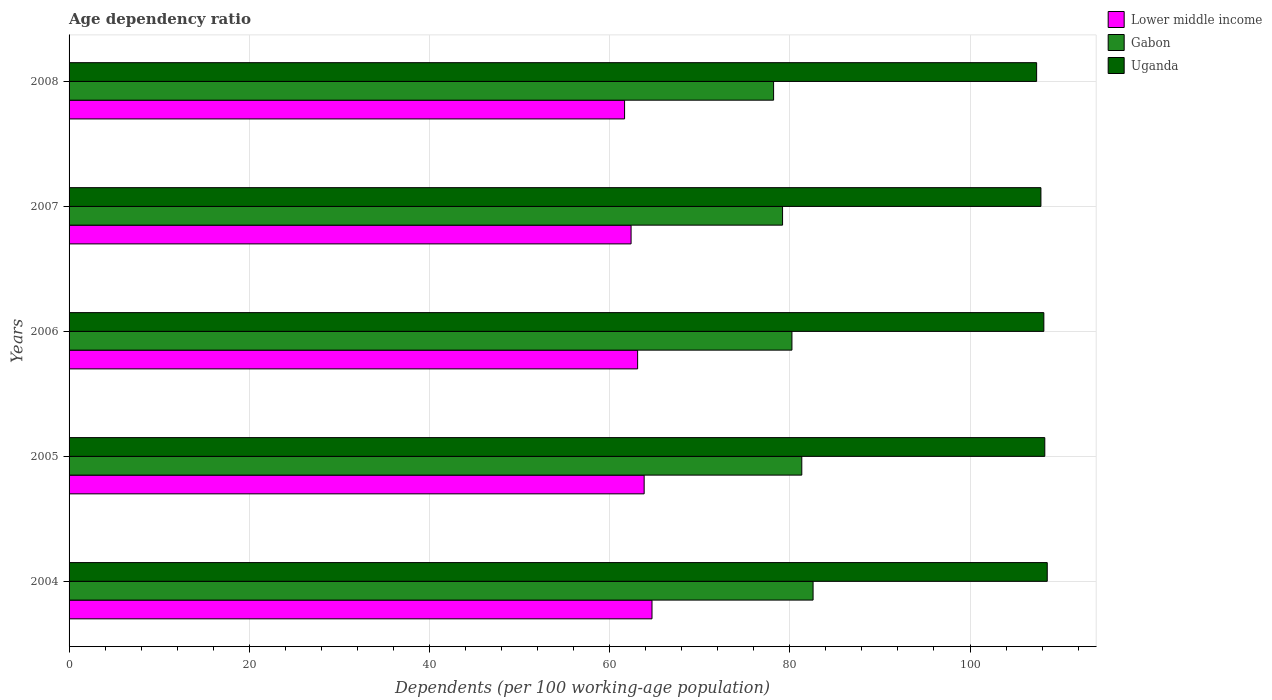How many different coloured bars are there?
Your response must be concise. 3. How many bars are there on the 4th tick from the top?
Make the answer very short. 3. How many bars are there on the 5th tick from the bottom?
Offer a terse response. 3. In how many cases, is the number of bars for a given year not equal to the number of legend labels?
Your answer should be very brief. 0. What is the age dependency ratio in in Uganda in 2006?
Give a very brief answer. 108.19. Across all years, what is the maximum age dependency ratio in in Gabon?
Offer a very short reply. 82.58. Across all years, what is the minimum age dependency ratio in in Lower middle income?
Give a very brief answer. 61.66. What is the total age dependency ratio in in Uganda in the graph?
Ensure brevity in your answer.  540.33. What is the difference between the age dependency ratio in in Uganda in 2004 and that in 2007?
Your answer should be compact. 0.7. What is the difference between the age dependency ratio in in Lower middle income in 2004 and the age dependency ratio in in Uganda in 2008?
Offer a terse response. -42.69. What is the average age dependency ratio in in Uganda per year?
Offer a very short reply. 108.07. In the year 2007, what is the difference between the age dependency ratio in in Gabon and age dependency ratio in in Lower middle income?
Provide a short and direct response. 16.81. What is the ratio of the age dependency ratio in in Gabon in 2005 to that in 2007?
Provide a succinct answer. 1.03. Is the age dependency ratio in in Lower middle income in 2005 less than that in 2006?
Your response must be concise. No. Is the difference between the age dependency ratio in in Gabon in 2005 and 2008 greater than the difference between the age dependency ratio in in Lower middle income in 2005 and 2008?
Provide a succinct answer. Yes. What is the difference between the highest and the second highest age dependency ratio in in Gabon?
Offer a terse response. 1.25. What is the difference between the highest and the lowest age dependency ratio in in Lower middle income?
Make the answer very short. 3.04. In how many years, is the age dependency ratio in in Gabon greater than the average age dependency ratio in in Gabon taken over all years?
Your answer should be very brief. 2. What does the 1st bar from the top in 2008 represents?
Give a very brief answer. Uganda. What does the 3rd bar from the bottom in 2006 represents?
Ensure brevity in your answer.  Uganda. Are all the bars in the graph horizontal?
Make the answer very short. Yes. How many years are there in the graph?
Your answer should be compact. 5. Are the values on the major ticks of X-axis written in scientific E-notation?
Offer a very short reply. No. Where does the legend appear in the graph?
Make the answer very short. Top right. How many legend labels are there?
Ensure brevity in your answer.  3. What is the title of the graph?
Provide a succinct answer. Age dependency ratio. Does "European Union" appear as one of the legend labels in the graph?
Your answer should be very brief. No. What is the label or title of the X-axis?
Ensure brevity in your answer.  Dependents (per 100 working-age population). What is the Dependents (per 100 working-age population) in Lower middle income in 2004?
Offer a terse response. 64.7. What is the Dependents (per 100 working-age population) of Gabon in 2004?
Give a very brief answer. 82.58. What is the Dependents (per 100 working-age population) of Uganda in 2004?
Make the answer very short. 108.57. What is the Dependents (per 100 working-age population) of Lower middle income in 2005?
Make the answer very short. 63.83. What is the Dependents (per 100 working-age population) of Gabon in 2005?
Give a very brief answer. 81.33. What is the Dependents (per 100 working-age population) of Uganda in 2005?
Give a very brief answer. 108.3. What is the Dependents (per 100 working-age population) of Lower middle income in 2006?
Make the answer very short. 63.11. What is the Dependents (per 100 working-age population) in Gabon in 2006?
Your answer should be compact. 80.23. What is the Dependents (per 100 working-age population) in Uganda in 2006?
Your answer should be very brief. 108.19. What is the Dependents (per 100 working-age population) in Lower middle income in 2007?
Your answer should be very brief. 62.38. What is the Dependents (per 100 working-age population) in Gabon in 2007?
Make the answer very short. 79.19. What is the Dependents (per 100 working-age population) of Uganda in 2007?
Provide a short and direct response. 107.87. What is the Dependents (per 100 working-age population) of Lower middle income in 2008?
Provide a succinct answer. 61.66. What is the Dependents (per 100 working-age population) in Gabon in 2008?
Your answer should be very brief. 78.2. What is the Dependents (per 100 working-age population) in Uganda in 2008?
Give a very brief answer. 107.39. Across all years, what is the maximum Dependents (per 100 working-age population) in Lower middle income?
Make the answer very short. 64.7. Across all years, what is the maximum Dependents (per 100 working-age population) in Gabon?
Keep it short and to the point. 82.58. Across all years, what is the maximum Dependents (per 100 working-age population) in Uganda?
Give a very brief answer. 108.57. Across all years, what is the minimum Dependents (per 100 working-age population) in Lower middle income?
Your response must be concise. 61.66. Across all years, what is the minimum Dependents (per 100 working-age population) of Gabon?
Make the answer very short. 78.2. Across all years, what is the minimum Dependents (per 100 working-age population) of Uganda?
Provide a succinct answer. 107.39. What is the total Dependents (per 100 working-age population) of Lower middle income in the graph?
Your answer should be very brief. 315.68. What is the total Dependents (per 100 working-age population) in Gabon in the graph?
Provide a short and direct response. 401.54. What is the total Dependents (per 100 working-age population) of Uganda in the graph?
Offer a terse response. 540.33. What is the difference between the Dependents (per 100 working-age population) of Lower middle income in 2004 and that in 2005?
Ensure brevity in your answer.  0.87. What is the difference between the Dependents (per 100 working-age population) of Gabon in 2004 and that in 2005?
Provide a short and direct response. 1.25. What is the difference between the Dependents (per 100 working-age population) of Uganda in 2004 and that in 2005?
Provide a short and direct response. 0.27. What is the difference between the Dependents (per 100 working-age population) of Lower middle income in 2004 and that in 2006?
Provide a succinct answer. 1.59. What is the difference between the Dependents (per 100 working-age population) in Gabon in 2004 and that in 2006?
Offer a terse response. 2.35. What is the difference between the Dependents (per 100 working-age population) in Uganda in 2004 and that in 2006?
Your answer should be compact. 0.38. What is the difference between the Dependents (per 100 working-age population) of Lower middle income in 2004 and that in 2007?
Your answer should be very brief. 2.32. What is the difference between the Dependents (per 100 working-age population) in Gabon in 2004 and that in 2007?
Your response must be concise. 3.39. What is the difference between the Dependents (per 100 working-age population) in Uganda in 2004 and that in 2007?
Ensure brevity in your answer.  0.7. What is the difference between the Dependents (per 100 working-age population) in Lower middle income in 2004 and that in 2008?
Your response must be concise. 3.04. What is the difference between the Dependents (per 100 working-age population) of Gabon in 2004 and that in 2008?
Ensure brevity in your answer.  4.38. What is the difference between the Dependents (per 100 working-age population) of Uganda in 2004 and that in 2008?
Provide a succinct answer. 1.18. What is the difference between the Dependents (per 100 working-age population) of Lower middle income in 2005 and that in 2006?
Your answer should be very brief. 0.72. What is the difference between the Dependents (per 100 working-age population) of Gabon in 2005 and that in 2006?
Your answer should be compact. 1.1. What is the difference between the Dependents (per 100 working-age population) in Uganda in 2005 and that in 2006?
Your response must be concise. 0.11. What is the difference between the Dependents (per 100 working-age population) of Lower middle income in 2005 and that in 2007?
Your answer should be compact. 1.45. What is the difference between the Dependents (per 100 working-age population) of Gabon in 2005 and that in 2007?
Your response must be concise. 2.13. What is the difference between the Dependents (per 100 working-age population) of Uganda in 2005 and that in 2007?
Ensure brevity in your answer.  0.43. What is the difference between the Dependents (per 100 working-age population) in Lower middle income in 2005 and that in 2008?
Make the answer very short. 2.17. What is the difference between the Dependents (per 100 working-age population) of Gabon in 2005 and that in 2008?
Your answer should be very brief. 3.13. What is the difference between the Dependents (per 100 working-age population) of Uganda in 2005 and that in 2008?
Provide a succinct answer. 0.91. What is the difference between the Dependents (per 100 working-age population) of Lower middle income in 2006 and that in 2007?
Your answer should be very brief. 0.73. What is the difference between the Dependents (per 100 working-age population) in Gabon in 2006 and that in 2007?
Give a very brief answer. 1.04. What is the difference between the Dependents (per 100 working-age population) of Uganda in 2006 and that in 2007?
Your answer should be very brief. 0.32. What is the difference between the Dependents (per 100 working-age population) in Lower middle income in 2006 and that in 2008?
Offer a terse response. 1.45. What is the difference between the Dependents (per 100 working-age population) of Gabon in 2006 and that in 2008?
Offer a very short reply. 2.04. What is the difference between the Dependents (per 100 working-age population) of Uganda in 2006 and that in 2008?
Give a very brief answer. 0.8. What is the difference between the Dependents (per 100 working-age population) of Lower middle income in 2007 and that in 2008?
Provide a succinct answer. 0.72. What is the difference between the Dependents (per 100 working-age population) of Gabon in 2007 and that in 2008?
Offer a very short reply. 1. What is the difference between the Dependents (per 100 working-age population) of Uganda in 2007 and that in 2008?
Give a very brief answer. 0.48. What is the difference between the Dependents (per 100 working-age population) of Lower middle income in 2004 and the Dependents (per 100 working-age population) of Gabon in 2005?
Your answer should be very brief. -16.63. What is the difference between the Dependents (per 100 working-age population) in Lower middle income in 2004 and the Dependents (per 100 working-age population) in Uganda in 2005?
Provide a short and direct response. -43.6. What is the difference between the Dependents (per 100 working-age population) of Gabon in 2004 and the Dependents (per 100 working-age population) of Uganda in 2005?
Your answer should be very brief. -25.72. What is the difference between the Dependents (per 100 working-age population) of Lower middle income in 2004 and the Dependents (per 100 working-age population) of Gabon in 2006?
Offer a very short reply. -15.53. What is the difference between the Dependents (per 100 working-age population) of Lower middle income in 2004 and the Dependents (per 100 working-age population) of Uganda in 2006?
Provide a short and direct response. -43.49. What is the difference between the Dependents (per 100 working-age population) in Gabon in 2004 and the Dependents (per 100 working-age population) in Uganda in 2006?
Offer a terse response. -25.61. What is the difference between the Dependents (per 100 working-age population) of Lower middle income in 2004 and the Dependents (per 100 working-age population) of Gabon in 2007?
Your answer should be compact. -14.49. What is the difference between the Dependents (per 100 working-age population) of Lower middle income in 2004 and the Dependents (per 100 working-age population) of Uganda in 2007?
Provide a short and direct response. -43.17. What is the difference between the Dependents (per 100 working-age population) in Gabon in 2004 and the Dependents (per 100 working-age population) in Uganda in 2007?
Ensure brevity in your answer.  -25.29. What is the difference between the Dependents (per 100 working-age population) of Lower middle income in 2004 and the Dependents (per 100 working-age population) of Gabon in 2008?
Ensure brevity in your answer.  -13.5. What is the difference between the Dependents (per 100 working-age population) in Lower middle income in 2004 and the Dependents (per 100 working-age population) in Uganda in 2008?
Ensure brevity in your answer.  -42.69. What is the difference between the Dependents (per 100 working-age population) in Gabon in 2004 and the Dependents (per 100 working-age population) in Uganda in 2008?
Provide a succinct answer. -24.81. What is the difference between the Dependents (per 100 working-age population) in Lower middle income in 2005 and the Dependents (per 100 working-age population) in Gabon in 2006?
Keep it short and to the point. -16.4. What is the difference between the Dependents (per 100 working-age population) in Lower middle income in 2005 and the Dependents (per 100 working-age population) in Uganda in 2006?
Provide a succinct answer. -44.36. What is the difference between the Dependents (per 100 working-age population) of Gabon in 2005 and the Dependents (per 100 working-age population) of Uganda in 2006?
Keep it short and to the point. -26.87. What is the difference between the Dependents (per 100 working-age population) of Lower middle income in 2005 and the Dependents (per 100 working-age population) of Gabon in 2007?
Keep it short and to the point. -15.36. What is the difference between the Dependents (per 100 working-age population) of Lower middle income in 2005 and the Dependents (per 100 working-age population) of Uganda in 2007?
Offer a terse response. -44.04. What is the difference between the Dependents (per 100 working-age population) in Gabon in 2005 and the Dependents (per 100 working-age population) in Uganda in 2007?
Keep it short and to the point. -26.54. What is the difference between the Dependents (per 100 working-age population) in Lower middle income in 2005 and the Dependents (per 100 working-age population) in Gabon in 2008?
Make the answer very short. -14.37. What is the difference between the Dependents (per 100 working-age population) in Lower middle income in 2005 and the Dependents (per 100 working-age population) in Uganda in 2008?
Make the answer very short. -43.56. What is the difference between the Dependents (per 100 working-age population) in Gabon in 2005 and the Dependents (per 100 working-age population) in Uganda in 2008?
Keep it short and to the point. -26.06. What is the difference between the Dependents (per 100 working-age population) in Lower middle income in 2006 and the Dependents (per 100 working-age population) in Gabon in 2007?
Provide a succinct answer. -16.09. What is the difference between the Dependents (per 100 working-age population) of Lower middle income in 2006 and the Dependents (per 100 working-age population) of Uganda in 2007?
Keep it short and to the point. -44.76. What is the difference between the Dependents (per 100 working-age population) in Gabon in 2006 and the Dependents (per 100 working-age population) in Uganda in 2007?
Your answer should be very brief. -27.64. What is the difference between the Dependents (per 100 working-age population) in Lower middle income in 2006 and the Dependents (per 100 working-age population) in Gabon in 2008?
Your answer should be compact. -15.09. What is the difference between the Dependents (per 100 working-age population) of Lower middle income in 2006 and the Dependents (per 100 working-age population) of Uganda in 2008?
Ensure brevity in your answer.  -44.29. What is the difference between the Dependents (per 100 working-age population) of Gabon in 2006 and the Dependents (per 100 working-age population) of Uganda in 2008?
Offer a terse response. -27.16. What is the difference between the Dependents (per 100 working-age population) in Lower middle income in 2007 and the Dependents (per 100 working-age population) in Gabon in 2008?
Give a very brief answer. -15.82. What is the difference between the Dependents (per 100 working-age population) of Lower middle income in 2007 and the Dependents (per 100 working-age population) of Uganda in 2008?
Your answer should be compact. -45.01. What is the difference between the Dependents (per 100 working-age population) in Gabon in 2007 and the Dependents (per 100 working-age population) in Uganda in 2008?
Make the answer very short. -28.2. What is the average Dependents (per 100 working-age population) in Lower middle income per year?
Offer a very short reply. 63.14. What is the average Dependents (per 100 working-age population) in Gabon per year?
Provide a succinct answer. 80.31. What is the average Dependents (per 100 working-age population) of Uganda per year?
Provide a succinct answer. 108.07. In the year 2004, what is the difference between the Dependents (per 100 working-age population) in Lower middle income and Dependents (per 100 working-age population) in Gabon?
Your response must be concise. -17.88. In the year 2004, what is the difference between the Dependents (per 100 working-age population) in Lower middle income and Dependents (per 100 working-age population) in Uganda?
Provide a short and direct response. -43.87. In the year 2004, what is the difference between the Dependents (per 100 working-age population) of Gabon and Dependents (per 100 working-age population) of Uganda?
Offer a very short reply. -25.99. In the year 2005, what is the difference between the Dependents (per 100 working-age population) of Lower middle income and Dependents (per 100 working-age population) of Gabon?
Make the answer very short. -17.5. In the year 2005, what is the difference between the Dependents (per 100 working-age population) of Lower middle income and Dependents (per 100 working-age population) of Uganda?
Provide a succinct answer. -44.47. In the year 2005, what is the difference between the Dependents (per 100 working-age population) in Gabon and Dependents (per 100 working-age population) in Uganda?
Give a very brief answer. -26.97. In the year 2006, what is the difference between the Dependents (per 100 working-age population) in Lower middle income and Dependents (per 100 working-age population) in Gabon?
Your response must be concise. -17.13. In the year 2006, what is the difference between the Dependents (per 100 working-age population) in Lower middle income and Dependents (per 100 working-age population) in Uganda?
Your response must be concise. -45.09. In the year 2006, what is the difference between the Dependents (per 100 working-age population) of Gabon and Dependents (per 100 working-age population) of Uganda?
Offer a terse response. -27.96. In the year 2007, what is the difference between the Dependents (per 100 working-age population) in Lower middle income and Dependents (per 100 working-age population) in Gabon?
Your answer should be very brief. -16.81. In the year 2007, what is the difference between the Dependents (per 100 working-age population) of Lower middle income and Dependents (per 100 working-age population) of Uganda?
Your response must be concise. -45.49. In the year 2007, what is the difference between the Dependents (per 100 working-age population) of Gabon and Dependents (per 100 working-age population) of Uganda?
Provide a short and direct response. -28.68. In the year 2008, what is the difference between the Dependents (per 100 working-age population) in Lower middle income and Dependents (per 100 working-age population) in Gabon?
Give a very brief answer. -16.54. In the year 2008, what is the difference between the Dependents (per 100 working-age population) of Lower middle income and Dependents (per 100 working-age population) of Uganda?
Ensure brevity in your answer.  -45.73. In the year 2008, what is the difference between the Dependents (per 100 working-age population) of Gabon and Dependents (per 100 working-age population) of Uganda?
Your answer should be very brief. -29.2. What is the ratio of the Dependents (per 100 working-age population) in Lower middle income in 2004 to that in 2005?
Keep it short and to the point. 1.01. What is the ratio of the Dependents (per 100 working-age population) in Gabon in 2004 to that in 2005?
Provide a succinct answer. 1.02. What is the ratio of the Dependents (per 100 working-age population) in Uganda in 2004 to that in 2005?
Give a very brief answer. 1. What is the ratio of the Dependents (per 100 working-age population) of Lower middle income in 2004 to that in 2006?
Provide a short and direct response. 1.03. What is the ratio of the Dependents (per 100 working-age population) in Gabon in 2004 to that in 2006?
Offer a terse response. 1.03. What is the ratio of the Dependents (per 100 working-age population) in Uganda in 2004 to that in 2006?
Your response must be concise. 1. What is the ratio of the Dependents (per 100 working-age population) in Lower middle income in 2004 to that in 2007?
Your answer should be compact. 1.04. What is the ratio of the Dependents (per 100 working-age population) in Gabon in 2004 to that in 2007?
Keep it short and to the point. 1.04. What is the ratio of the Dependents (per 100 working-age population) of Lower middle income in 2004 to that in 2008?
Offer a terse response. 1.05. What is the ratio of the Dependents (per 100 working-age population) in Gabon in 2004 to that in 2008?
Give a very brief answer. 1.06. What is the ratio of the Dependents (per 100 working-age population) in Lower middle income in 2005 to that in 2006?
Offer a terse response. 1.01. What is the ratio of the Dependents (per 100 working-age population) of Gabon in 2005 to that in 2006?
Give a very brief answer. 1.01. What is the ratio of the Dependents (per 100 working-age population) of Lower middle income in 2005 to that in 2007?
Your answer should be very brief. 1.02. What is the ratio of the Dependents (per 100 working-age population) of Uganda in 2005 to that in 2007?
Keep it short and to the point. 1. What is the ratio of the Dependents (per 100 working-age population) in Lower middle income in 2005 to that in 2008?
Your answer should be very brief. 1.04. What is the ratio of the Dependents (per 100 working-age population) in Uganda in 2005 to that in 2008?
Give a very brief answer. 1.01. What is the ratio of the Dependents (per 100 working-age population) of Lower middle income in 2006 to that in 2007?
Provide a short and direct response. 1.01. What is the ratio of the Dependents (per 100 working-age population) of Gabon in 2006 to that in 2007?
Your response must be concise. 1.01. What is the ratio of the Dependents (per 100 working-age population) of Uganda in 2006 to that in 2007?
Provide a succinct answer. 1. What is the ratio of the Dependents (per 100 working-age population) in Lower middle income in 2006 to that in 2008?
Offer a very short reply. 1.02. What is the ratio of the Dependents (per 100 working-age population) of Uganda in 2006 to that in 2008?
Offer a very short reply. 1.01. What is the ratio of the Dependents (per 100 working-age population) of Lower middle income in 2007 to that in 2008?
Provide a succinct answer. 1.01. What is the ratio of the Dependents (per 100 working-age population) of Gabon in 2007 to that in 2008?
Ensure brevity in your answer.  1.01. What is the difference between the highest and the second highest Dependents (per 100 working-age population) of Lower middle income?
Your response must be concise. 0.87. What is the difference between the highest and the second highest Dependents (per 100 working-age population) in Gabon?
Keep it short and to the point. 1.25. What is the difference between the highest and the second highest Dependents (per 100 working-age population) in Uganda?
Provide a short and direct response. 0.27. What is the difference between the highest and the lowest Dependents (per 100 working-age population) in Lower middle income?
Offer a terse response. 3.04. What is the difference between the highest and the lowest Dependents (per 100 working-age population) in Gabon?
Offer a terse response. 4.38. What is the difference between the highest and the lowest Dependents (per 100 working-age population) in Uganda?
Keep it short and to the point. 1.18. 